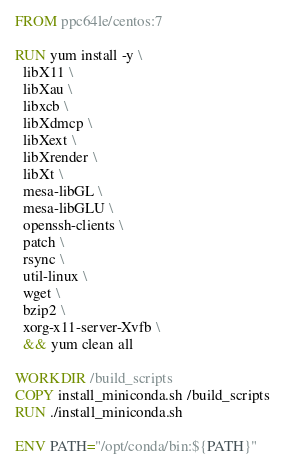<code> <loc_0><loc_0><loc_500><loc_500><_Dockerfile_>FROM ppc64le/centos:7

RUN yum install -y \
  libX11 \
  libXau \
  libxcb \
  libXdmcp \
  libXext \
  libXrender \
  libXt \
  mesa-libGL \
  mesa-libGLU \
  openssh-clients \
  patch \
  rsync \
  util-linux \
  wget \
  bzip2 \
  xorg-x11-server-Xvfb \
  && yum clean all

WORKDIR /build_scripts
COPY install_miniconda.sh /build_scripts
RUN ./install_miniconda.sh

ENV PATH="/opt/conda/bin:${PATH}"
</code> 